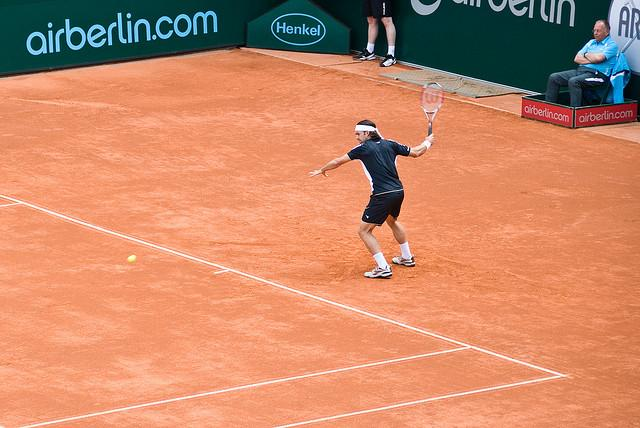In which country is the city mentioned here located? germany 